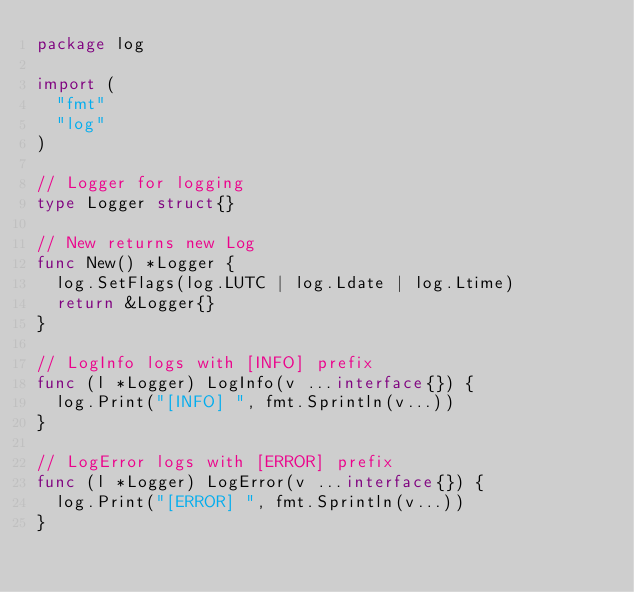<code> <loc_0><loc_0><loc_500><loc_500><_Go_>package log

import (
	"fmt"
	"log"
)

// Logger for logging
type Logger struct{}

// New returns new Log
func New() *Logger {
	log.SetFlags(log.LUTC | log.Ldate | log.Ltime)
	return &Logger{}
}

// LogInfo logs with [INFO] prefix
func (l *Logger) LogInfo(v ...interface{}) {
	log.Print("[INFO] ", fmt.Sprintln(v...))
}

// LogError logs with [ERROR] prefix
func (l *Logger) LogError(v ...interface{}) {
	log.Print("[ERROR] ", fmt.Sprintln(v...))
}
</code> 